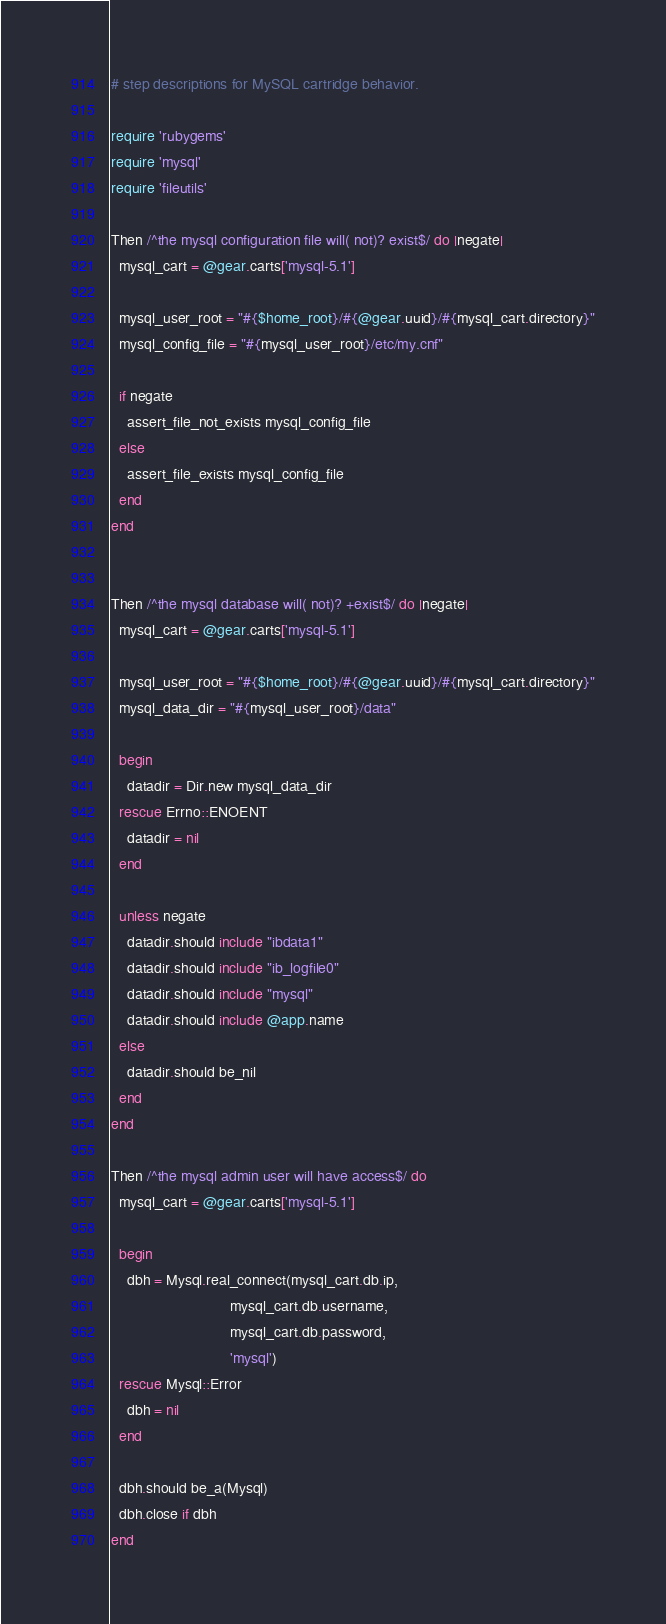<code> <loc_0><loc_0><loc_500><loc_500><_Ruby_># step descriptions for MySQL cartridge behavior.

require 'rubygems'
require 'mysql'
require 'fileutils'

Then /^the mysql configuration file will( not)? exist$/ do |negate|
  mysql_cart = @gear.carts['mysql-5.1']

  mysql_user_root = "#{$home_root}/#{@gear.uuid}/#{mysql_cart.directory}"
  mysql_config_file = "#{mysql_user_root}/etc/my.cnf"

  if negate
    assert_file_not_exists mysql_config_file
  else
    assert_file_exists mysql_config_file
  end
end


Then /^the mysql database will( not)? +exist$/ do |negate|
  mysql_cart = @gear.carts['mysql-5.1']

  mysql_user_root = "#{$home_root}/#{@gear.uuid}/#{mysql_cart.directory}"
  mysql_data_dir = "#{mysql_user_root}/data"

  begin
    datadir = Dir.new mysql_data_dir
  rescue Errno::ENOENT
    datadir = nil
  end

  unless negate
    datadir.should include "ibdata1"
    datadir.should include "ib_logfile0"
    datadir.should include "mysql"
    datadir.should include @app.name
  else
    datadir.should be_nil
  end
end

Then /^the mysql admin user will have access$/ do
  mysql_cart = @gear.carts['mysql-5.1']

  begin
    dbh = Mysql.real_connect(mysql_cart.db.ip, 
                             mysql_cart.db.username, 
                             mysql_cart.db.password,
                             'mysql')
  rescue Mysql::Error
    dbh = nil
  end

  dbh.should be_a(Mysql)
  dbh.close if dbh
end
</code> 